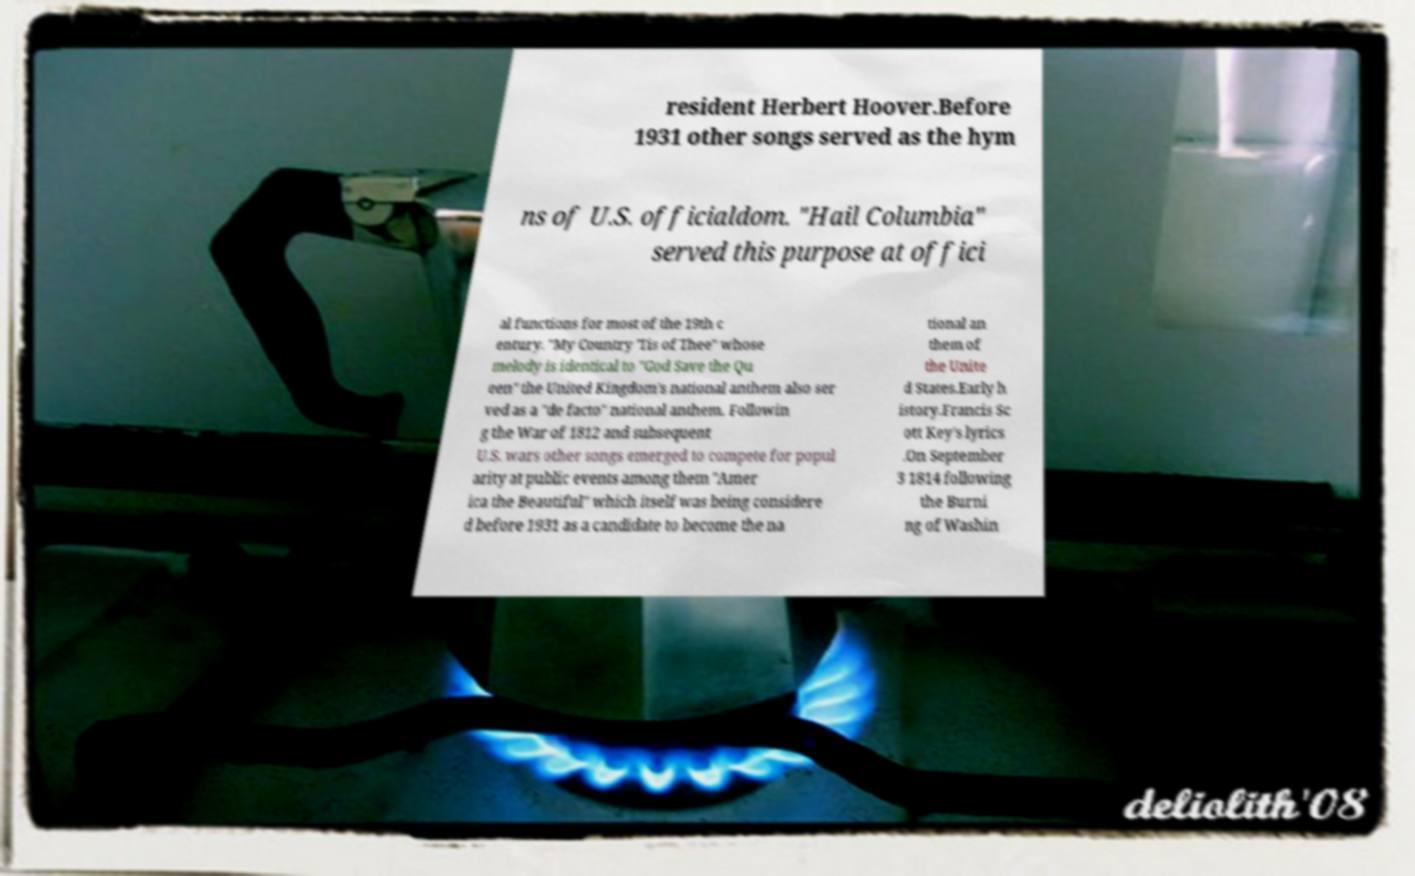There's text embedded in this image that I need extracted. Can you transcribe it verbatim? resident Herbert Hoover.Before 1931 other songs served as the hym ns of U.S. officialdom. "Hail Columbia" served this purpose at offici al functions for most of the 19th c entury. "My Country 'Tis of Thee" whose melody is identical to "God Save the Qu een" the United Kingdom's national anthem also ser ved as a "de facto" national anthem. Followin g the War of 1812 and subsequent U.S. wars other songs emerged to compete for popul arity at public events among them "Amer ica the Beautiful" which itself was being considere d before 1931 as a candidate to become the na tional an them of the Unite d States.Early h istory.Francis Sc ott Key's lyrics .On September 3 1814 following the Burni ng of Washin 